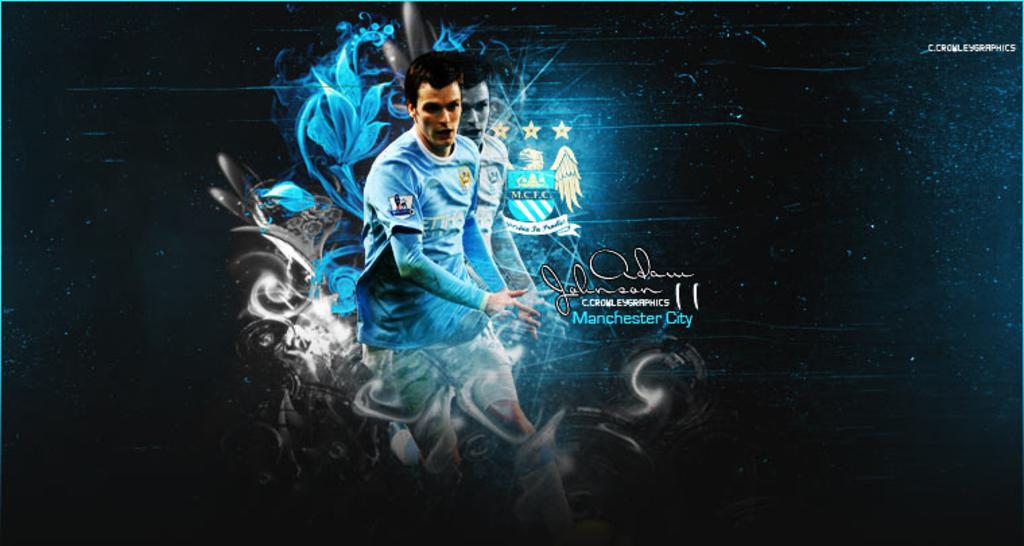Provide a one-sentence caption for the provided image. An athlete who plays for Manchester City is shown on an advertisement. 